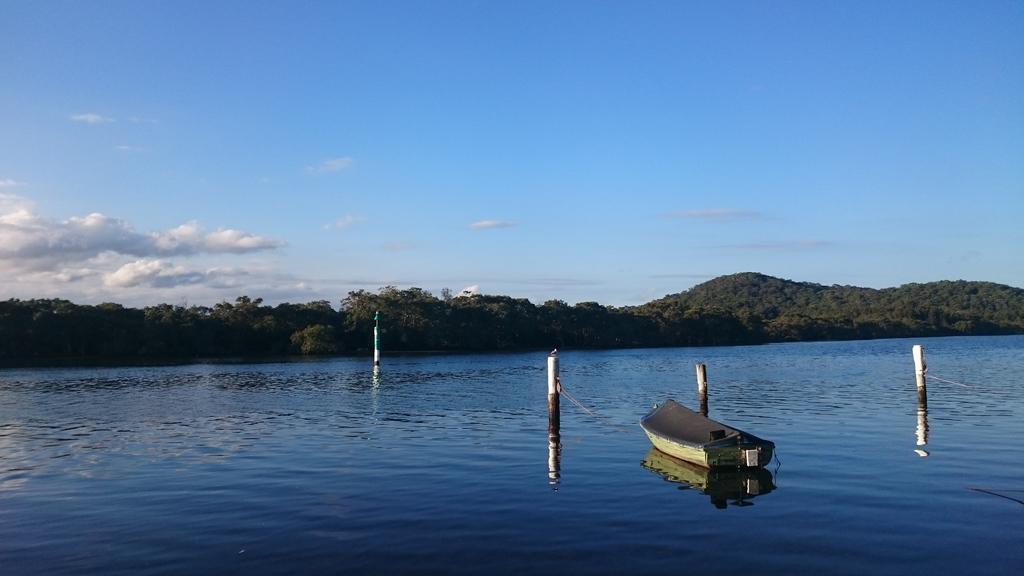Please provide a concise description of this image. In this image I can see a boat is on the water. I can see few poles in water. The water is in blue color. Back I can see a trees and mountains. The sky is in blue and white color. 